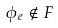<formula> <loc_0><loc_0><loc_500><loc_500>\phi _ { e } \notin F</formula> 